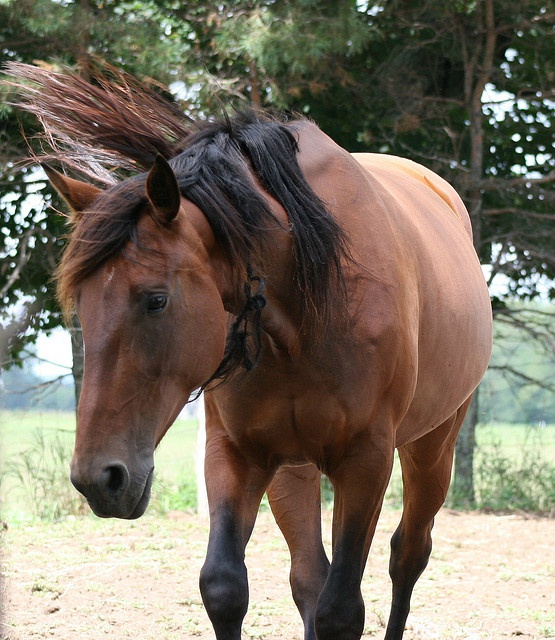Describe the objects in this image and their specific colors. I can see a horse in beige, black, maroon, and gray tones in this image. 